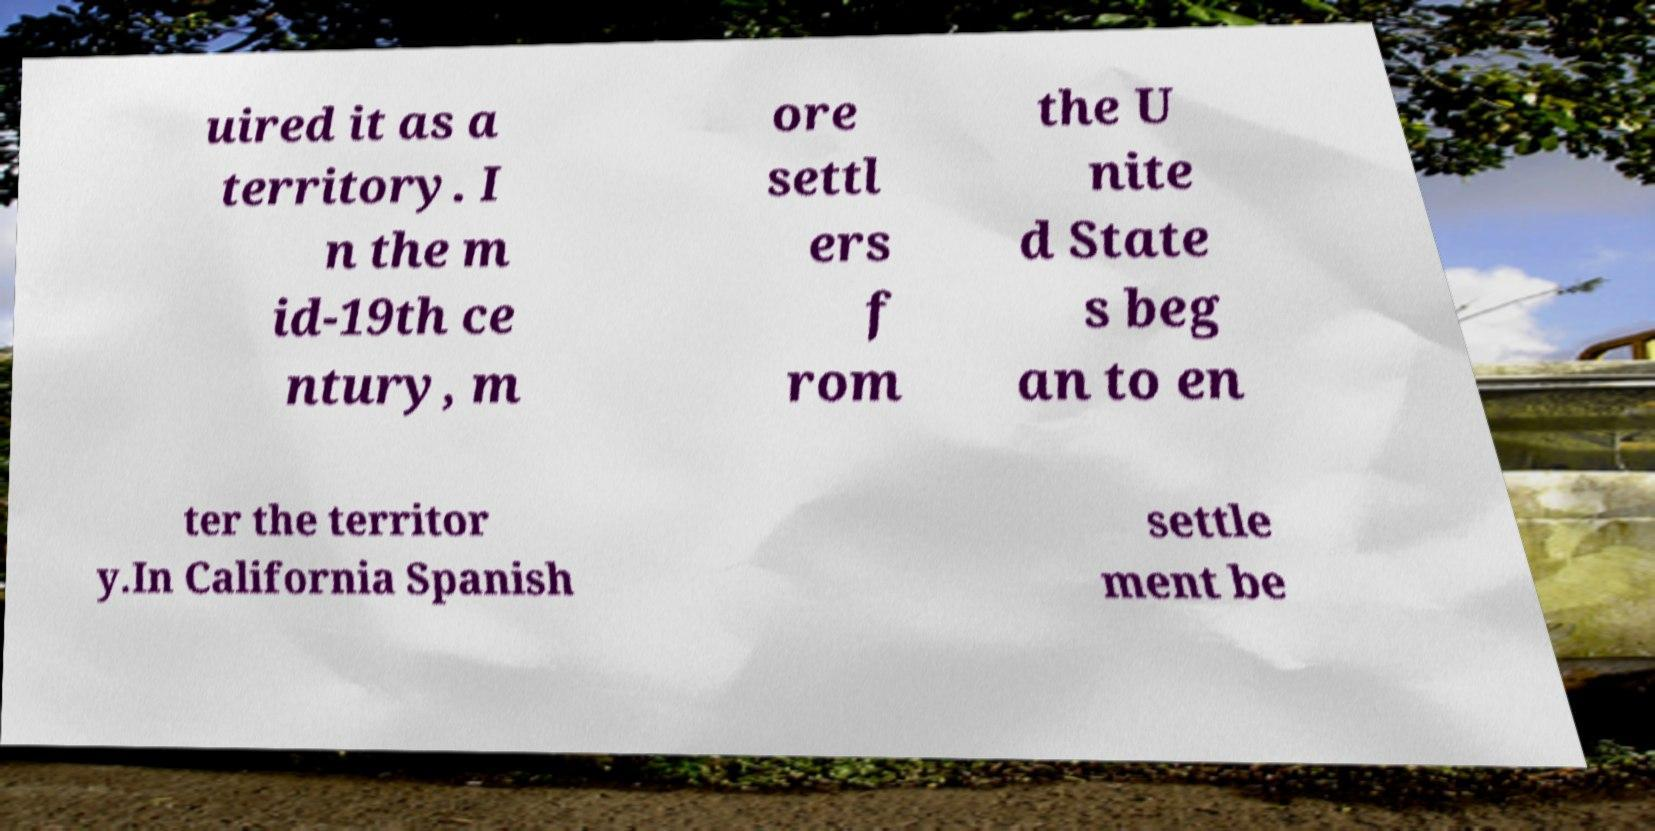Can you read and provide the text displayed in the image?This photo seems to have some interesting text. Can you extract and type it out for me? uired it as a territory. I n the m id-19th ce ntury, m ore settl ers f rom the U nite d State s beg an to en ter the territor y.In California Spanish settle ment be 